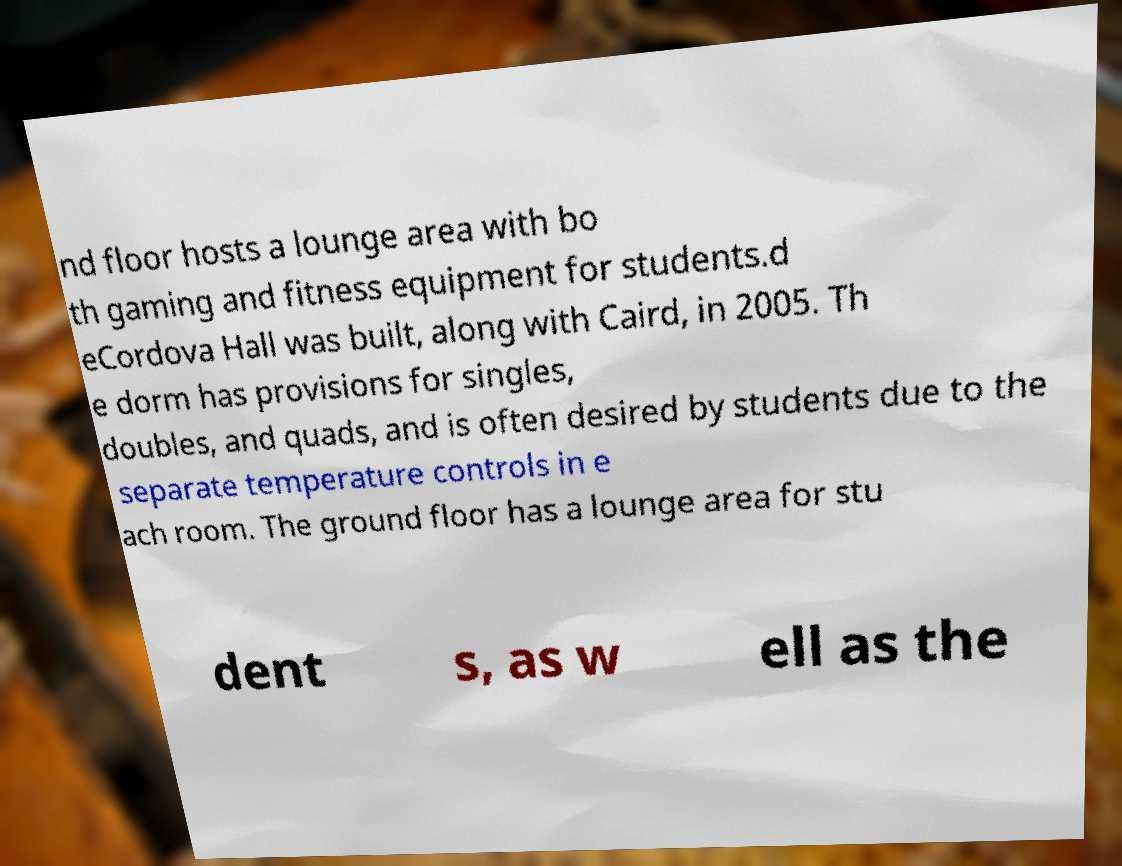What messages or text are displayed in this image? I need them in a readable, typed format. nd floor hosts a lounge area with bo th gaming and fitness equipment for students.d eCordova Hall was built, along with Caird, in 2005. Th e dorm has provisions for singles, doubles, and quads, and is often desired by students due to the separate temperature controls in e ach room. The ground floor has a lounge area for stu dent s, as w ell as the 